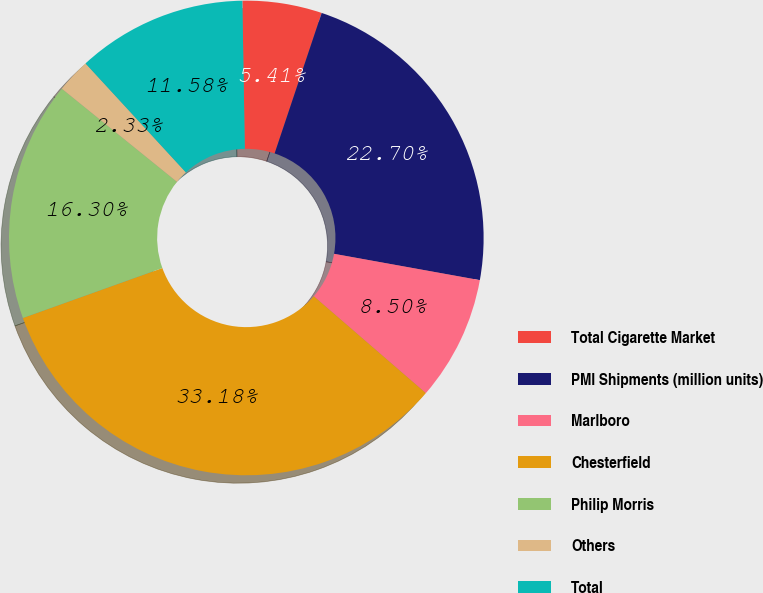Convert chart. <chart><loc_0><loc_0><loc_500><loc_500><pie_chart><fcel>Total Cigarette Market<fcel>PMI Shipments (million units)<fcel>Marlboro<fcel>Chesterfield<fcel>Philip Morris<fcel>Others<fcel>Total<nl><fcel>5.41%<fcel>22.7%<fcel>8.5%<fcel>33.18%<fcel>16.3%<fcel>2.33%<fcel>11.58%<nl></chart> 